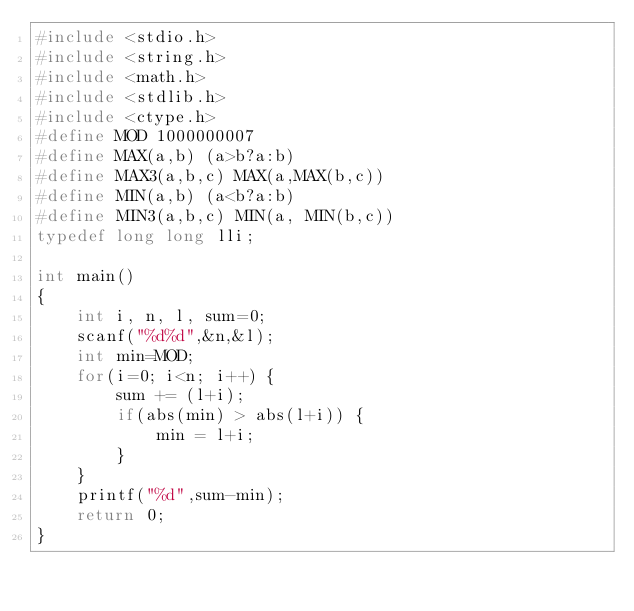<code> <loc_0><loc_0><loc_500><loc_500><_C_>#include <stdio.h>
#include <string.h>
#include <math.h>
#include <stdlib.h>
#include <ctype.h>
#define MOD 1000000007
#define MAX(a,b) (a>b?a:b)
#define MAX3(a,b,c) MAX(a,MAX(b,c))
#define MIN(a,b) (a<b?a:b)
#define MIN3(a,b,c) MIN(a, MIN(b,c))
typedef long long lli;

int main()
{
    int i, n, l, sum=0;
    scanf("%d%d",&n,&l);
    int min=MOD;
    for(i=0; i<n; i++) {
        sum += (l+i);
        if(abs(min) > abs(l+i)) {
            min = l+i;
        }
    }
    printf("%d",sum-min);
    return 0;
}
</code> 